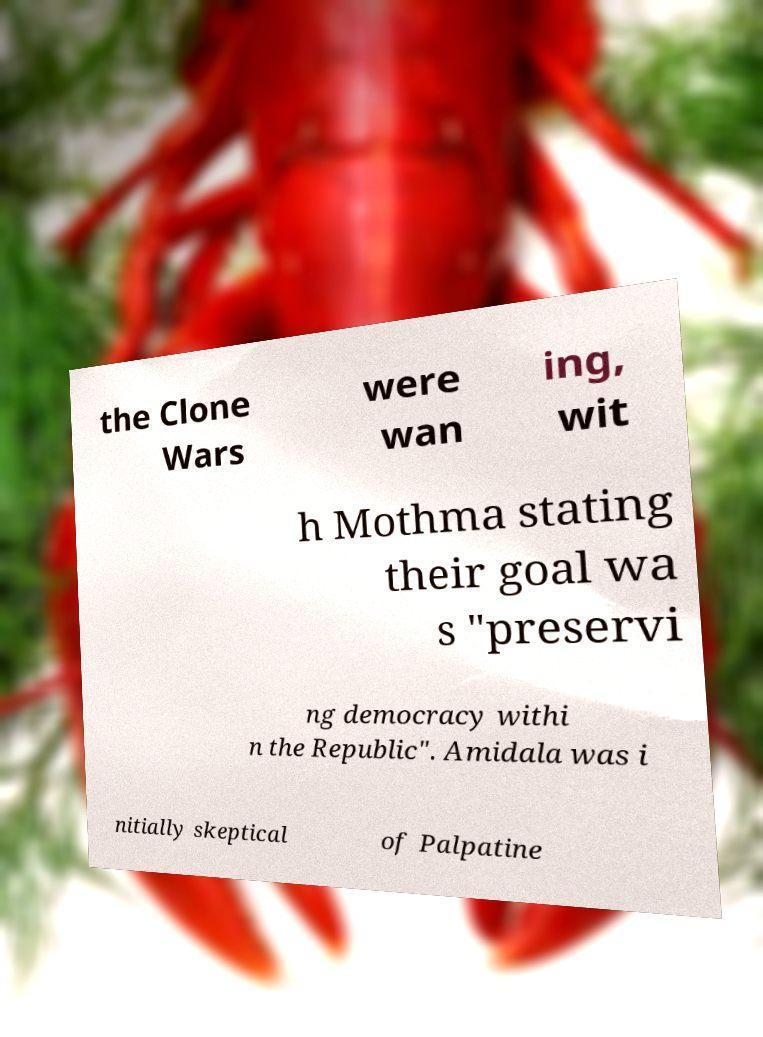Can you accurately transcribe the text from the provided image for me? the Clone Wars were wan ing, wit h Mothma stating their goal wa s "preservi ng democracy withi n the Republic". Amidala was i nitially skeptical of Palpatine 